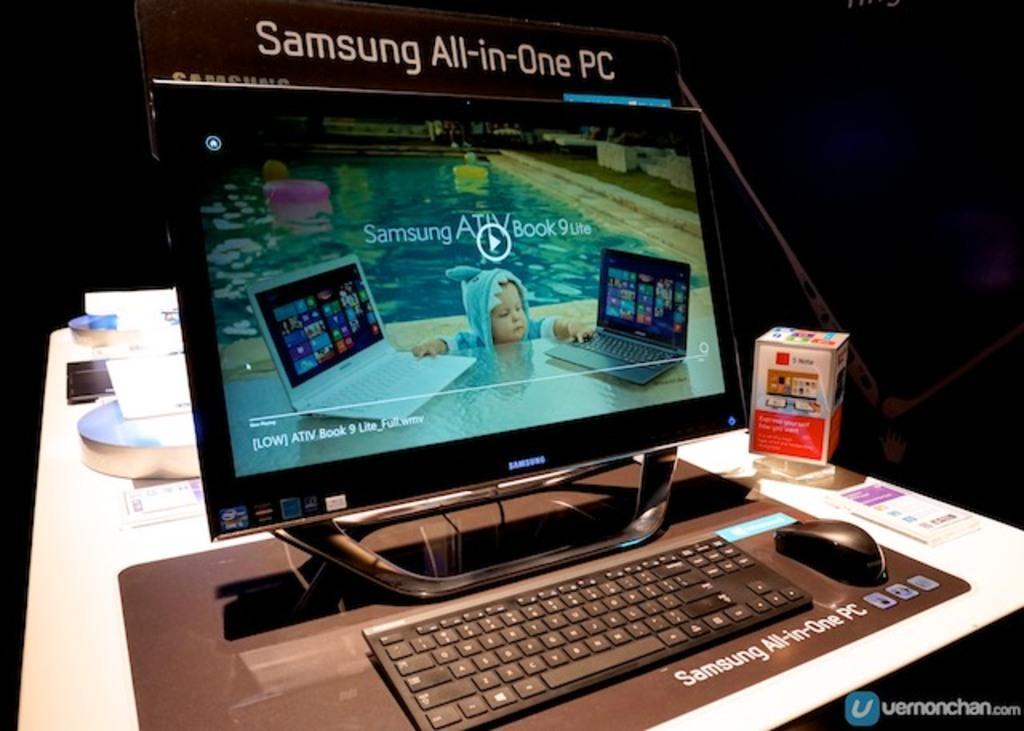Can you describe this image briefly? In the image there is a monitor with keyboard,mouse in front of it and a box beside it on a table and behind it there are some accessories on the table. 